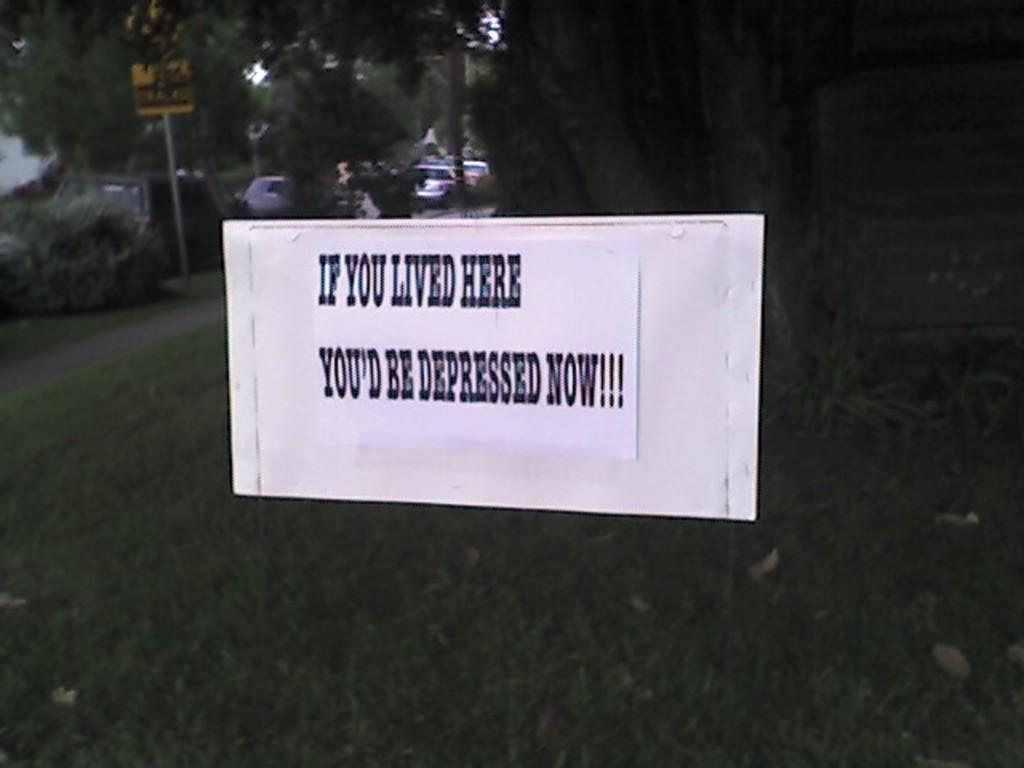What is the main object in the image? There is a white color board in the image. What is written or displayed on the white color board? There is text on the white color board. What can be seen in the background of the image? There are trees, grass, and cars on the road visible in the background of the image. How many pigs are playing the rhythm on the nail in the image? There are no pigs, nails, or any rhythm-related activities present in the image. 